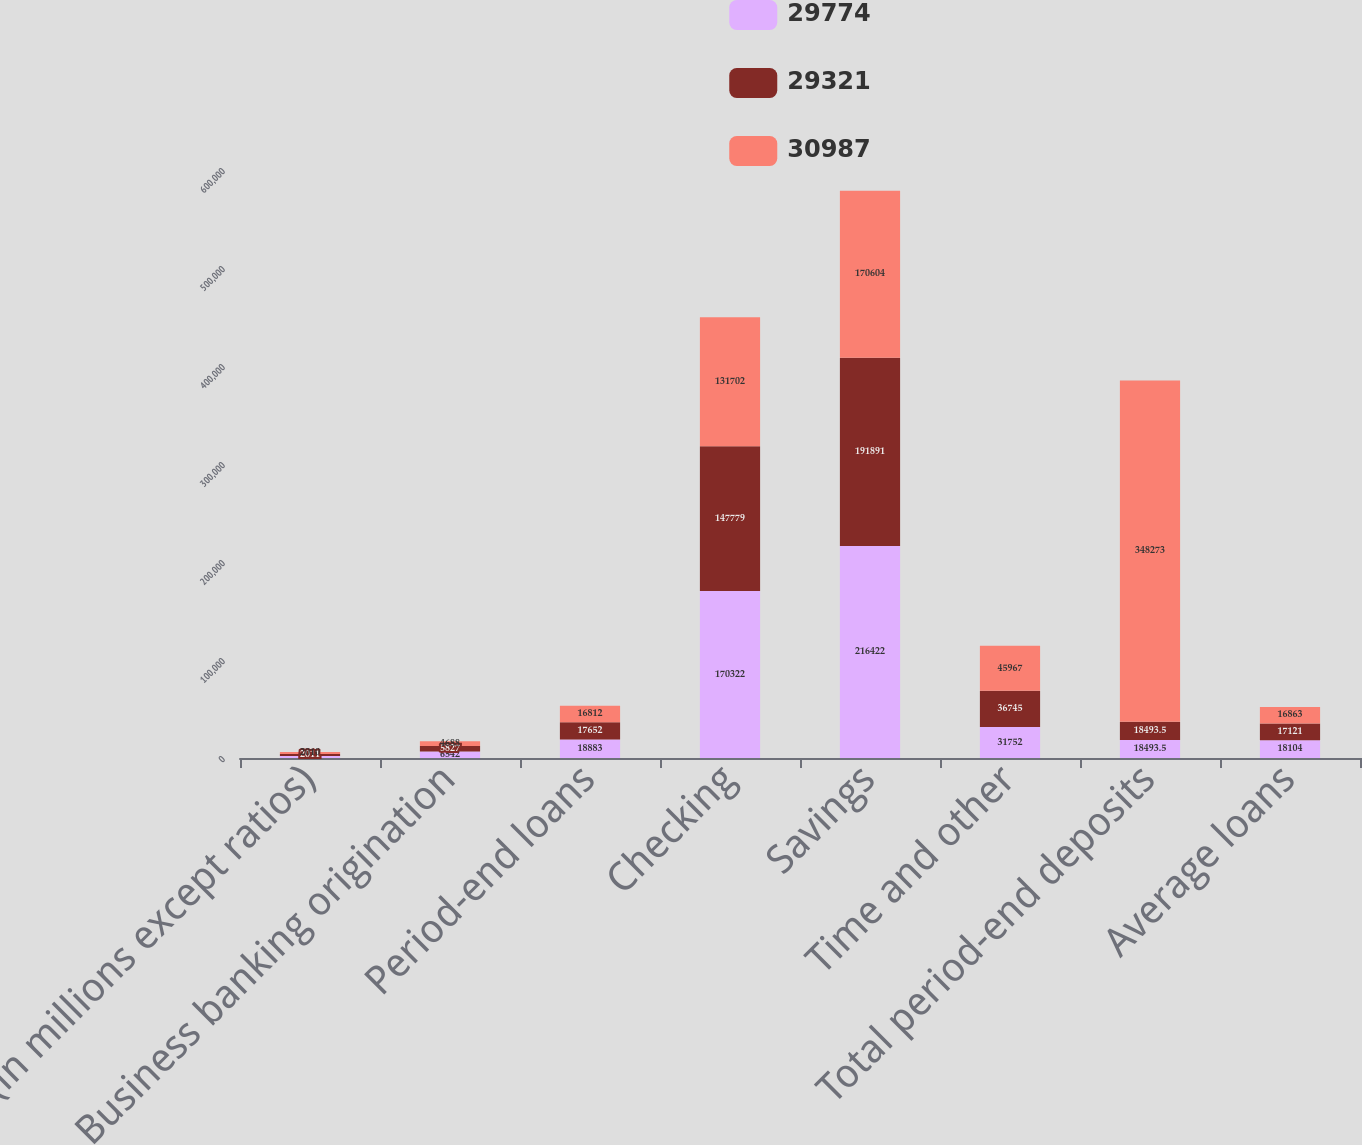<chart> <loc_0><loc_0><loc_500><loc_500><stacked_bar_chart><ecel><fcel>(in millions except ratios)<fcel>Business banking origination<fcel>Period-end loans<fcel>Checking<fcel>Savings<fcel>Time and other<fcel>Total period-end deposits<fcel>Average loans<nl><fcel>29774<fcel>2012<fcel>6542<fcel>18883<fcel>170322<fcel>216422<fcel>31752<fcel>18493.5<fcel>18104<nl><fcel>29321<fcel>2011<fcel>5827<fcel>17652<fcel>147779<fcel>191891<fcel>36745<fcel>18493.5<fcel>17121<nl><fcel>30987<fcel>2010<fcel>4688<fcel>16812<fcel>131702<fcel>170604<fcel>45967<fcel>348273<fcel>16863<nl></chart> 